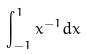Convert formula to latex. <formula><loc_0><loc_0><loc_500><loc_500>\int _ { - 1 } ^ { 1 } x ^ { - 1 } d x</formula> 